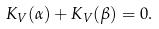Convert formula to latex. <formula><loc_0><loc_0><loc_500><loc_500>K _ { V } ( \alpha ) + K _ { V } ( \beta ) = 0 .</formula> 